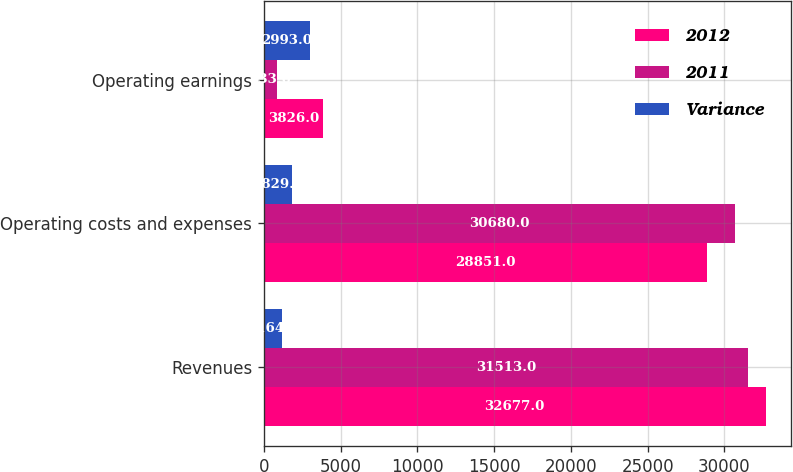Convert chart. <chart><loc_0><loc_0><loc_500><loc_500><stacked_bar_chart><ecel><fcel>Revenues<fcel>Operating costs and expenses<fcel>Operating earnings<nl><fcel>2012<fcel>32677<fcel>28851<fcel>3826<nl><fcel>2011<fcel>31513<fcel>30680<fcel>833<nl><fcel>Variance<fcel>1164<fcel>1829<fcel>2993<nl></chart> 